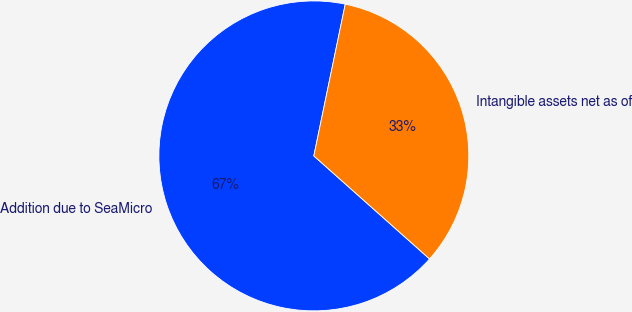<chart> <loc_0><loc_0><loc_500><loc_500><pie_chart><fcel>Addition due to SeaMicro<fcel>Intangible assets net as of<nl><fcel>66.67%<fcel>33.33%<nl></chart> 